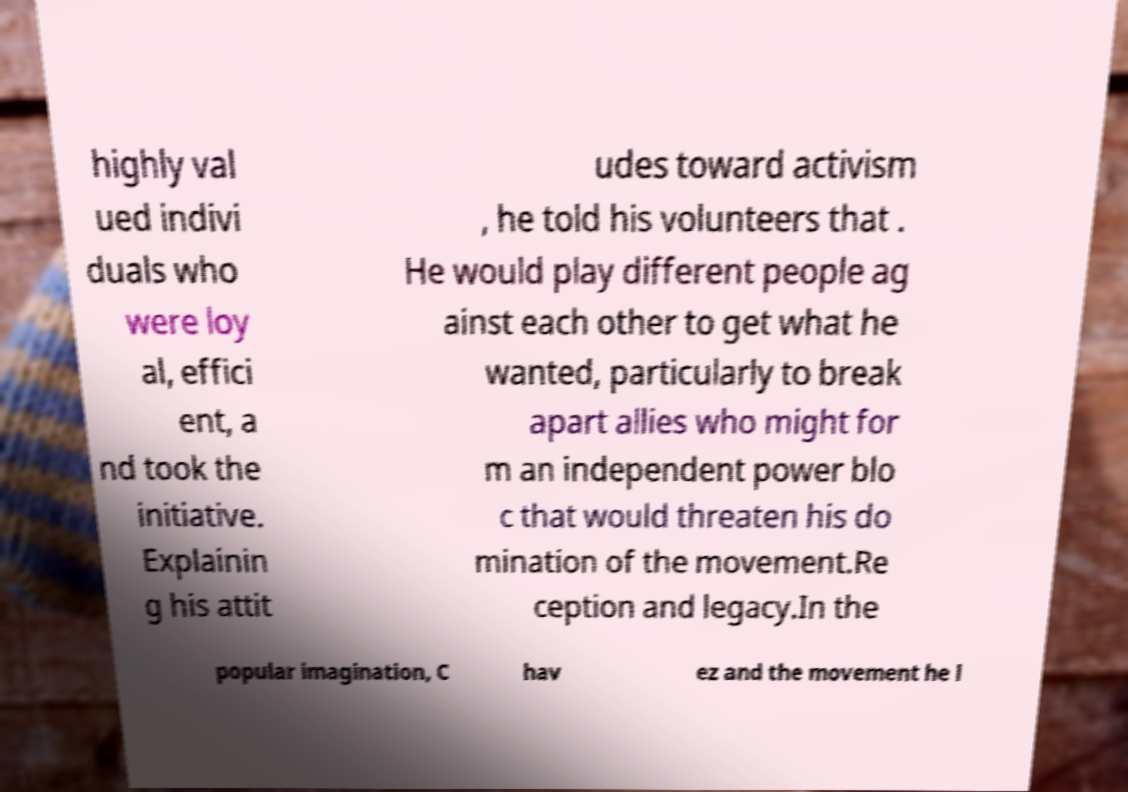What messages or text are displayed in this image? I need them in a readable, typed format. highly val ued indivi duals who were loy al, effici ent, a nd took the initiative. Explainin g his attit udes toward activism , he told his volunteers that . He would play different people ag ainst each other to get what he wanted, particularly to break apart allies who might for m an independent power blo c that would threaten his do mination of the movement.Re ception and legacy.In the popular imagination, C hav ez and the movement he l 